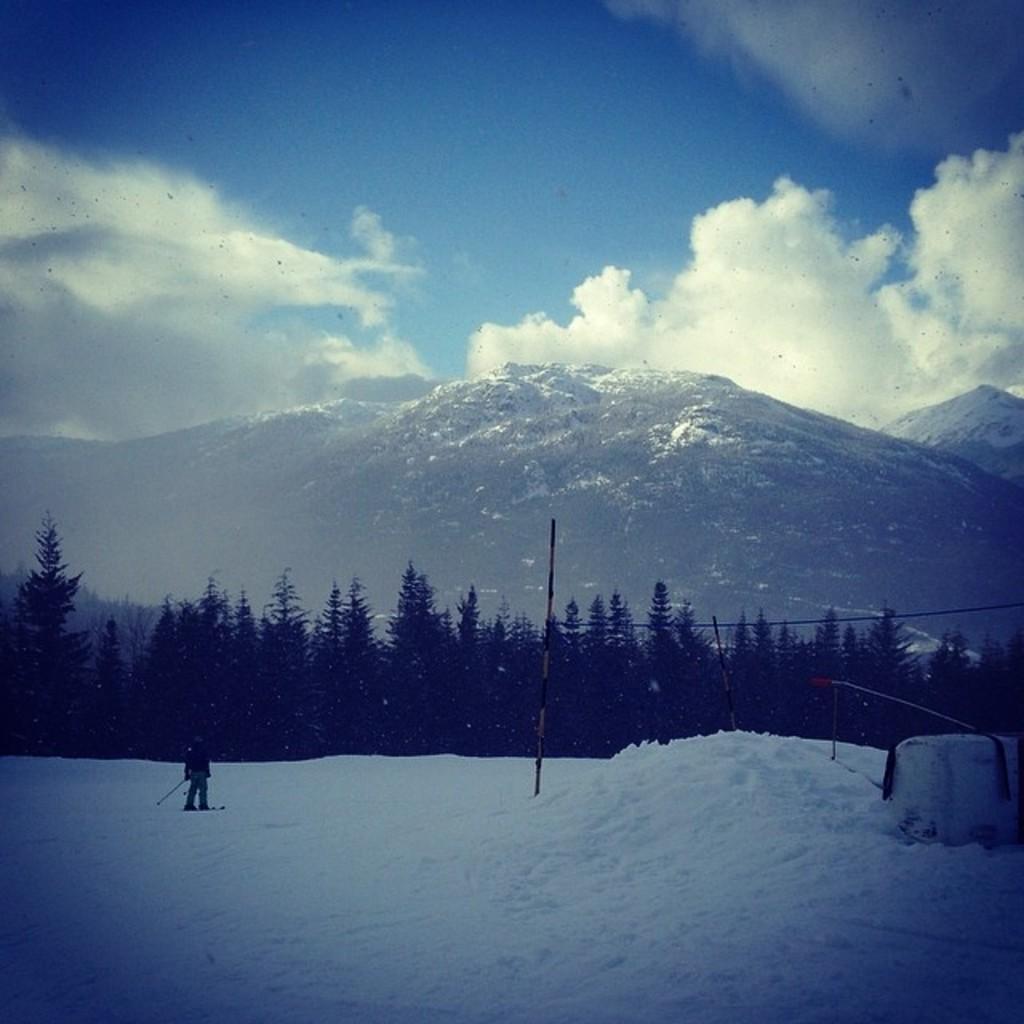What is the main feature of the landscape in the image? There is snow in the image. Can you describe the person in the image? There is a person standing in the image. What type of vegetation is present in the image? There are trees in the image. What geographical feature can be seen in the background of the image? There are mountains in the image. What is visible in the sky in the image? The sky is visible in the background of the image. What type of snail can be seen crawling on the person's jeans in the image? There is no snail or jeans present in the image; the person is standing in the snow. How does the beginner navigate the snowy terrain in the image? There is no indication of the person's experience level in the image, and no specific navigation method is depicted. 